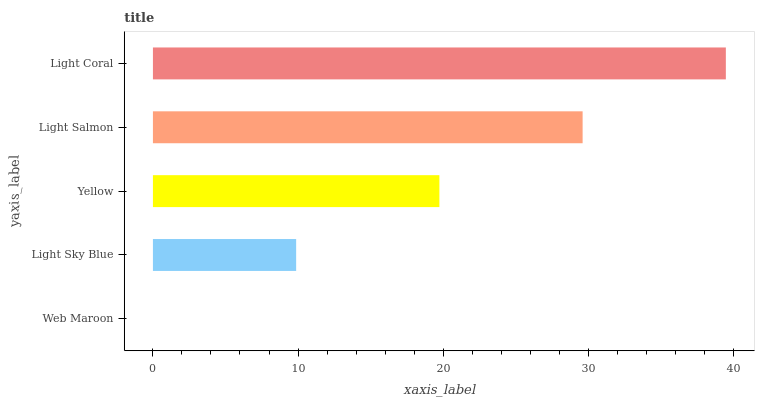Is Web Maroon the minimum?
Answer yes or no. Yes. Is Light Coral the maximum?
Answer yes or no. Yes. Is Light Sky Blue the minimum?
Answer yes or no. No. Is Light Sky Blue the maximum?
Answer yes or no. No. Is Light Sky Blue greater than Web Maroon?
Answer yes or no. Yes. Is Web Maroon less than Light Sky Blue?
Answer yes or no. Yes. Is Web Maroon greater than Light Sky Blue?
Answer yes or no. No. Is Light Sky Blue less than Web Maroon?
Answer yes or no. No. Is Yellow the high median?
Answer yes or no. Yes. Is Yellow the low median?
Answer yes or no. Yes. Is Light Coral the high median?
Answer yes or no. No. Is Web Maroon the low median?
Answer yes or no. No. 